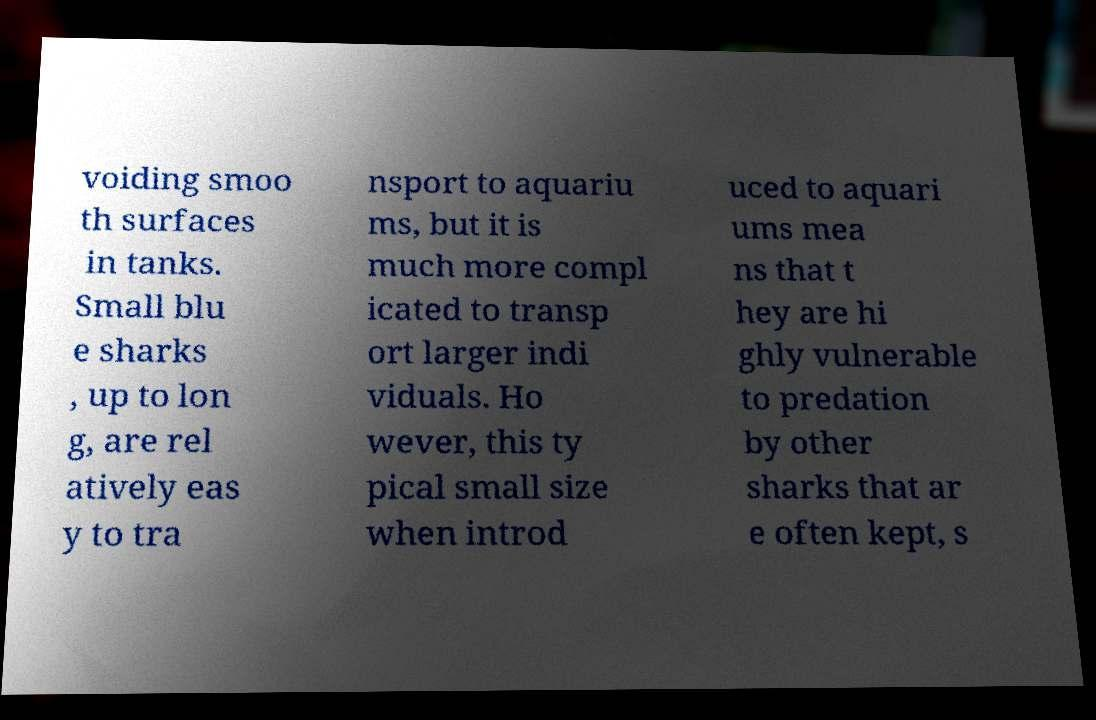I need the written content from this picture converted into text. Can you do that? voiding smoo th surfaces in tanks. Small blu e sharks , up to lon g, are rel atively eas y to tra nsport to aquariu ms, but it is much more compl icated to transp ort larger indi viduals. Ho wever, this ty pical small size when introd uced to aquari ums mea ns that t hey are hi ghly vulnerable to predation by other sharks that ar e often kept, s 